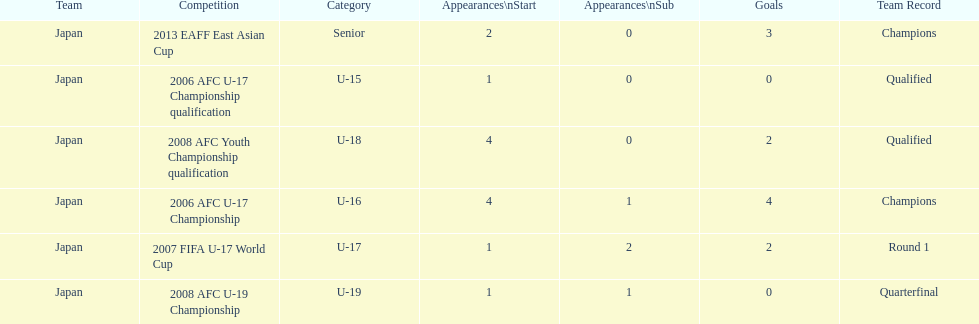Name the earliest competition to have a sub. 2006 AFC U-17 Championship. 